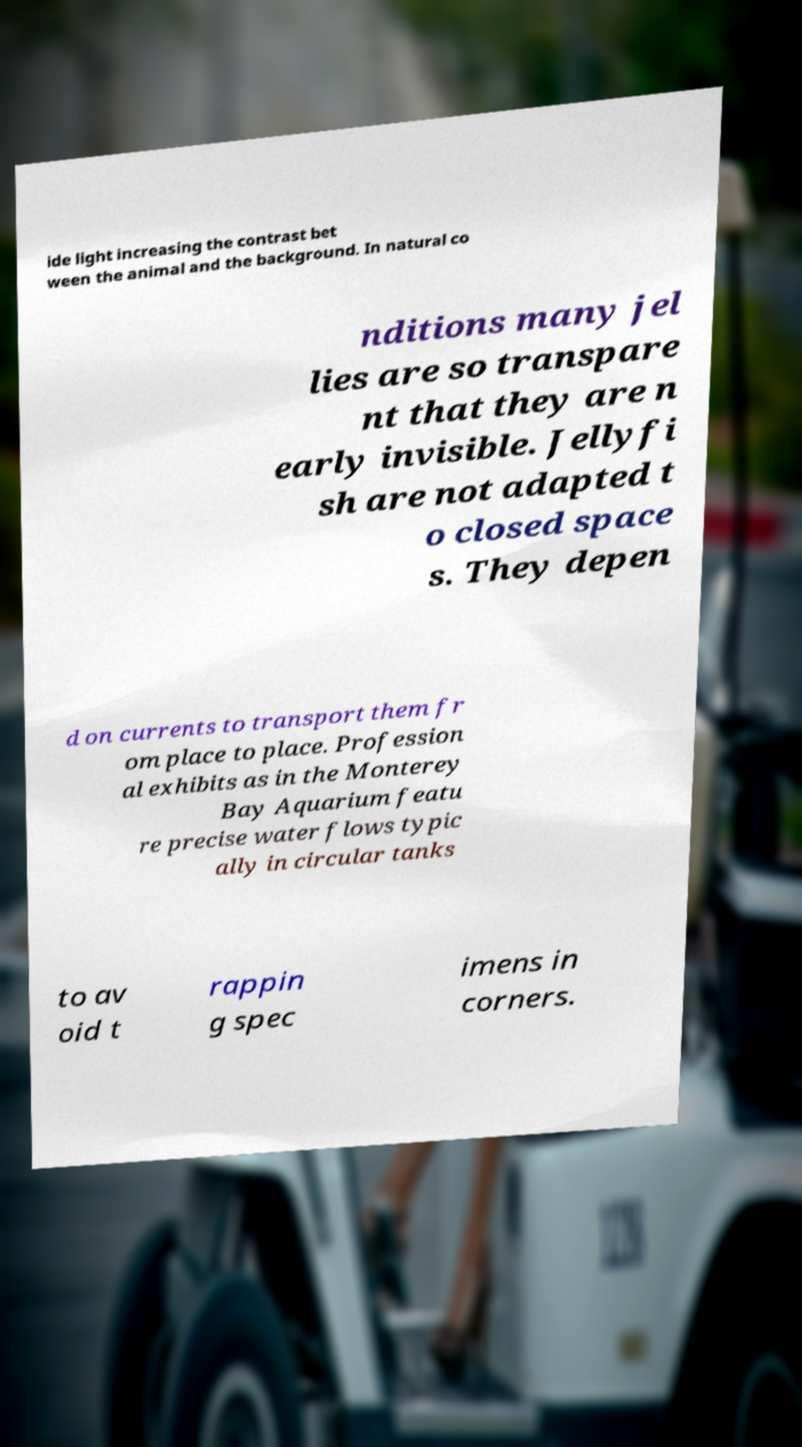Could you extract and type out the text from this image? ide light increasing the contrast bet ween the animal and the background. In natural co nditions many jel lies are so transpare nt that they are n early invisible. Jellyfi sh are not adapted t o closed space s. They depen d on currents to transport them fr om place to place. Profession al exhibits as in the Monterey Bay Aquarium featu re precise water flows typic ally in circular tanks to av oid t rappin g spec imens in corners. 